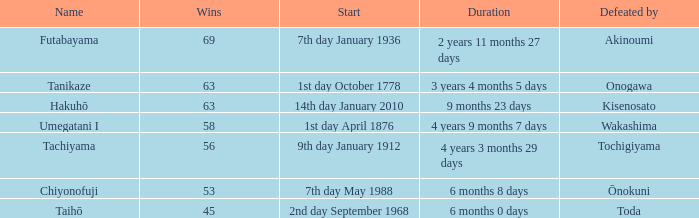How many wins were held before being defeated by toda? 1.0. 